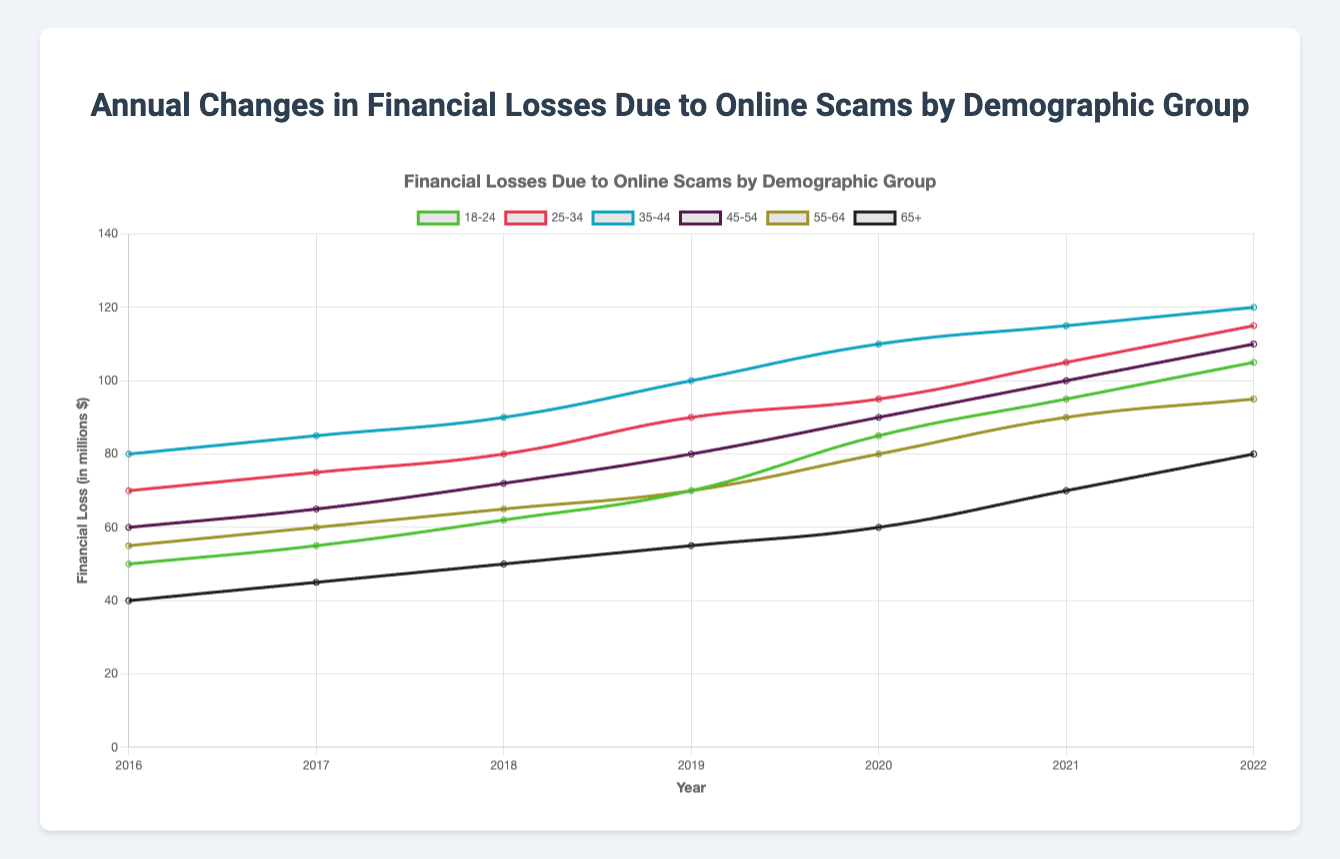What year did the "18-24" demographic group experience the highest financial losses due to online scams? To determine the year with the highest financial losses for the "18-24" demographic group, look at the line in the chart representing the financial losses for this group and identify the peak point.
Answer: 2022 Which demographic group saw the highest financial loss in 2018? To answer this, look at the data points for all demographic groups in the year 2018 and identify which group has the highest value.
Answer: 35-44 Between 2020 and 2022, which demographic group had the greatest increase in financial losses? Identify the financial loss values for each demographic group in 2020 and 2022. Calculate the difference for each group, and the group with the largest positive difference is the answer.
Answer: 18-24 How did the financial losses for the "55-64" group change from 2016 to 2021? Subtract the 2016 financial losses from the 2021 financial losses for the "55-64" demographic group to determine the change. (2021: 90; 2016: 55)
Answer: +35 Compare the financial losses of the "45-54" and "65+" groups in 2022. Which group experienced higher losses? Check the financial loss values for "45-54" and "65+" in 2022. Compare the two values to see which is larger. (45-54: 110; 65+: 80)
Answer: 45-54 What is the average financial loss for the "35-44" group from 2016 to 2022? Sum the financial loss values for the "35-44" group from each year (2016: 80, 2017: 85, 2018: 90, 2019: 100, 2020: 110, 2021: 115, 2022: 120). Divide the total by the number of years (7). The formula is (80 + 85 + 90 + 100 + 110 + 115 + 120) / 7.
Answer: 100 In which year did the "25-34" group last experience a financial loss of less than 80 million dollars? Locate the financial loss values for the "25-34" group and notice the last year it was below 80 million dollars.
Answer: 2017 Which demographic group shows a consistent increase in financial losses from 2016 to 2022? Look at the trend lines for all demographic groups and identify the one that shows a consistent upward trend without any dips.
Answer: 18-24 Visualizing the "65+" group, how does the slope of their line from 2016 to 2022 compare to the "25-34" group? Compare the steepness and direction of the lines representing the financial losses of the "65+" and "25-34" groups. Notice if one slope is steeper or more gradual.
Answer: More gradual What is the total financial loss for the "45-54" group across all years combined? Sum the financial loss values for the "45-54" group from 2016 to 2022. (60 + 65 + 72 + 80 + 90 + 100 + 110)
Answer: 577 